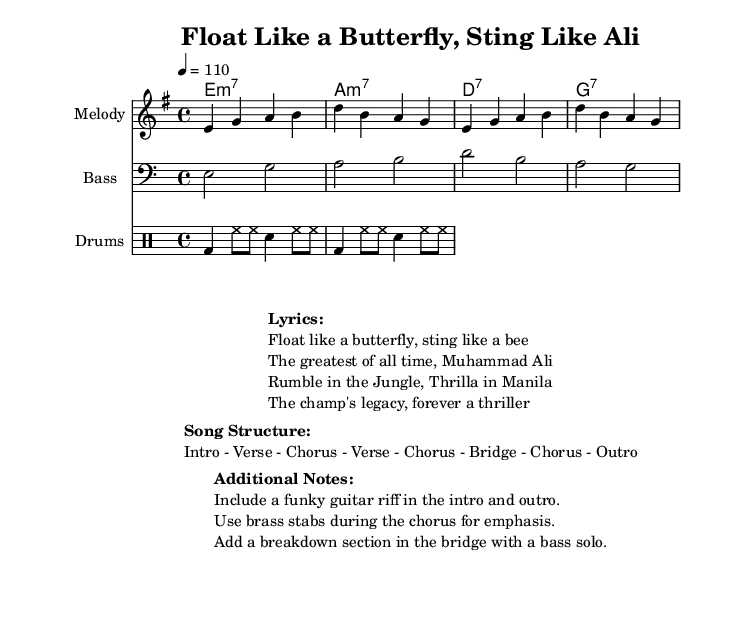What is the key signature of this music? The key signature is E minor, which has one sharp (F#). It is indicated at the beginning of the score in the key signature section.
Answer: E minor What is the time signature of this music? The time signature is 4/4, meaning there are four beats in each measure and the quarter note receives one beat. This can be found at the beginning of the score in the time signature section.
Answer: 4/4 What is the tempo marking for this piece? The tempo marking is 4 = 110, which means the quarter note should be played at a tempo of 110 beats per minute. This is stated in the tempo section at the beginning of the score.
Answer: 110 How many verses are in the song structure? The song structure includes two verses, as explicitly noted in the provided song structure breakdown. The format lists "Verse - Chorus - Verse - Chorus."
Answer: 2 What instrument is highlighted for the melody? The melody is specifically labeled as being played on the "Melody" instrument. This is indicated at the start of the staff for the melody.
Answer: Melody What additional musical element is suggested for emphasis during the chorus? The additional musical element suggested for emphasis during the chorus is "brass stabs," which is included in the additional notes. This gives a funky feel and accentuates the chorus section.
Answer: Brass stabs What is the title of this song? The title is "Float Like a Butterfly, Sting Like Ali," which is found in the header section of the score.
Answer: Float Like a Butterfly, Sting Like Ali 